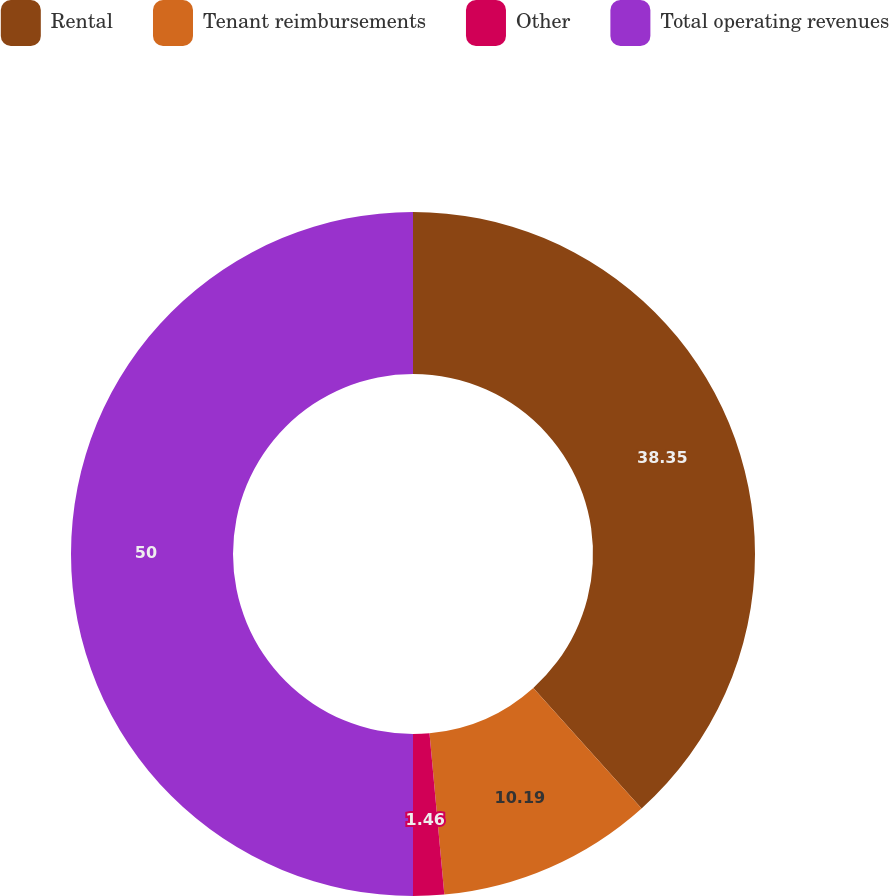<chart> <loc_0><loc_0><loc_500><loc_500><pie_chart><fcel>Rental<fcel>Tenant reimbursements<fcel>Other<fcel>Total operating revenues<nl><fcel>38.35%<fcel>10.19%<fcel>1.46%<fcel>50.0%<nl></chart> 